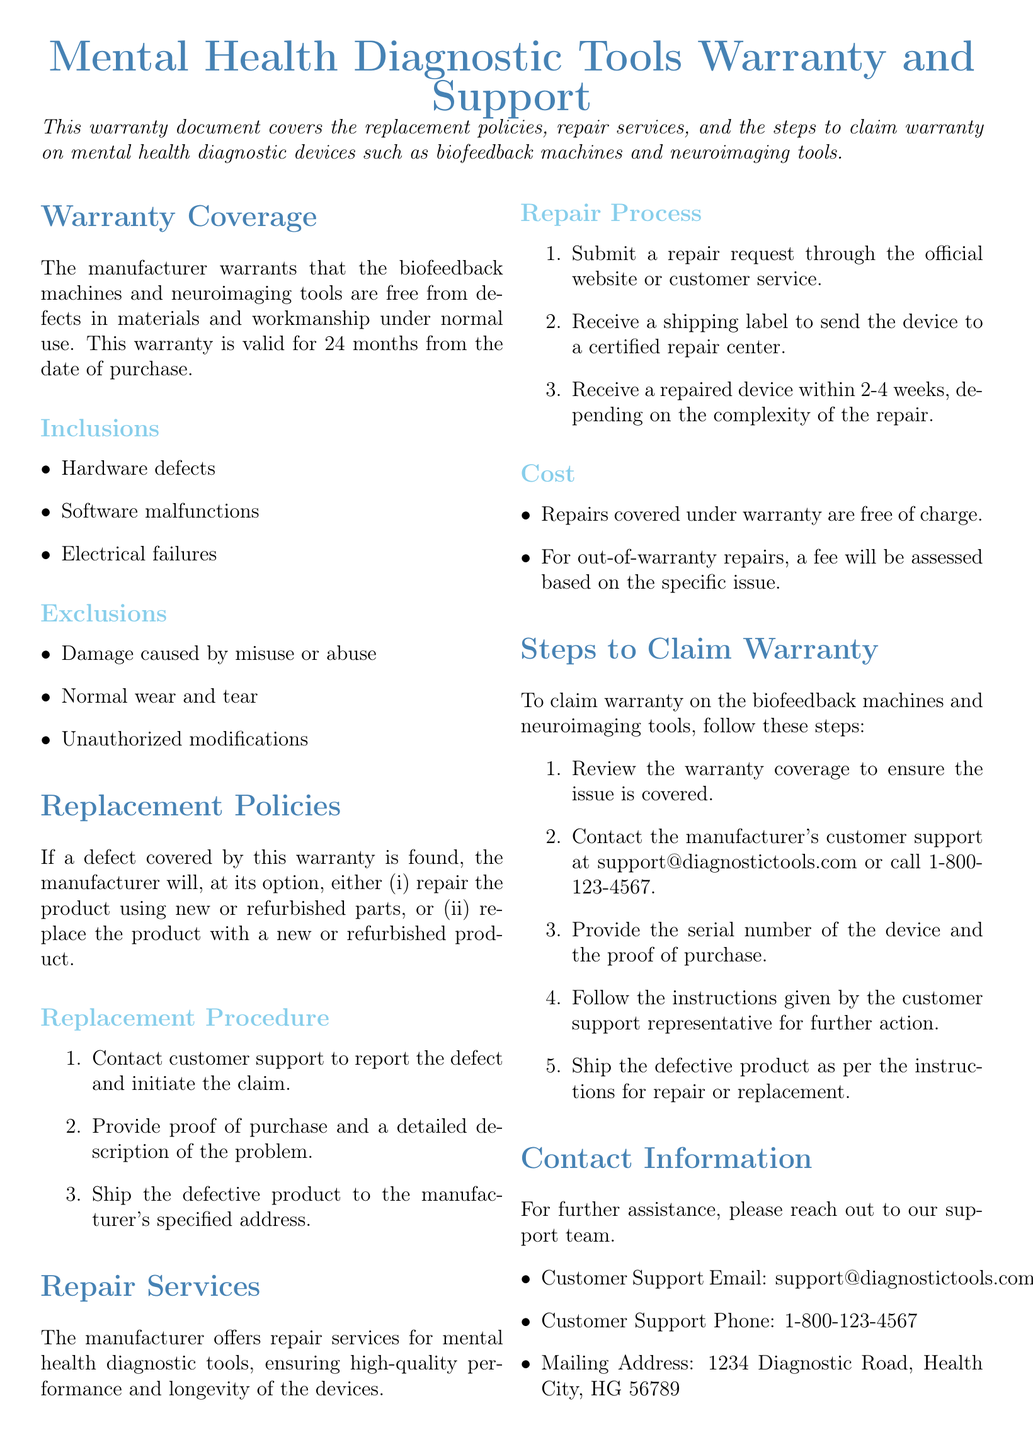What is the warranty period for the devices? The warranty period for the devices is stated as 24 months from the date of purchase.
Answer: 24 months What types of defects are covered under the warranty? The document lists inclusions that detail hardware defects, software malfunctions, and electrical failures as covered defects.
Answer: Hardware defects, software malfunctions, electrical failures What are the exclusions from the warranty coverage? Exclusions to the warranty specifically include damage caused by misuse or abuse, normal wear and tear, and unauthorized modifications.
Answer: Misuse or abuse, normal wear and tear, unauthorized modifications How long does it take to receive a repaired device? The document mentions that a repaired device will be returned within 2-4 weeks, depending on the complexity of the repair.
Answer: 2-4 weeks What is the first step to initiate a warranty claim? The first step to initiate a warranty claim is to contact customer support to report the defect and initiate the claim.
Answer: Contact customer support What is the contact email for customer support? The document provides an email address for customer support which is critical for warranty claims and inquiries.
Answer: support@diagnostictools.com What will the manufacturer do if a defect is found? If a defect is found, the manufacturer may either repair the product using new or refurbished parts or replace the product.
Answer: Repair or replace What is provided to send the device for repair? The document states that a shipping label will be provided to send the device to a certified repair center.
Answer: Shipping label What is the cost of repairs covered under warranty? The document explicitly states that repairs covered under warranty are free of charge.
Answer: Free of charge 